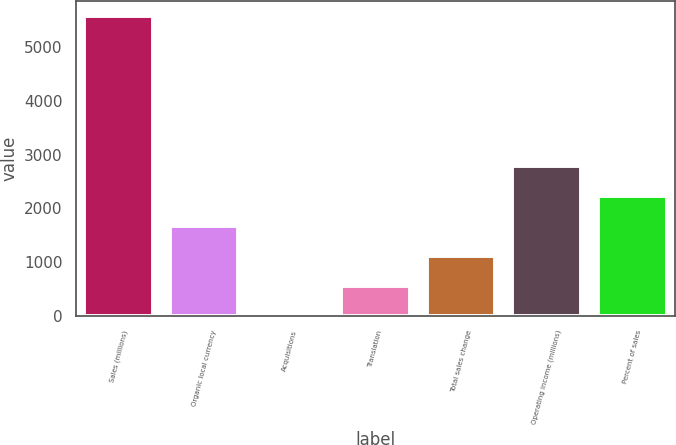<chart> <loc_0><loc_0><loc_500><loc_500><bar_chart><fcel>Sales (millions)<fcel>Organic local currency<fcel>Acquisitions<fcel>Translation<fcel>Total sales change<fcel>Operating income (millions)<fcel>Percent of sales<nl><fcel>5572<fcel>1671.88<fcel>0.4<fcel>557.56<fcel>1114.72<fcel>2786.2<fcel>2229.04<nl></chart> 